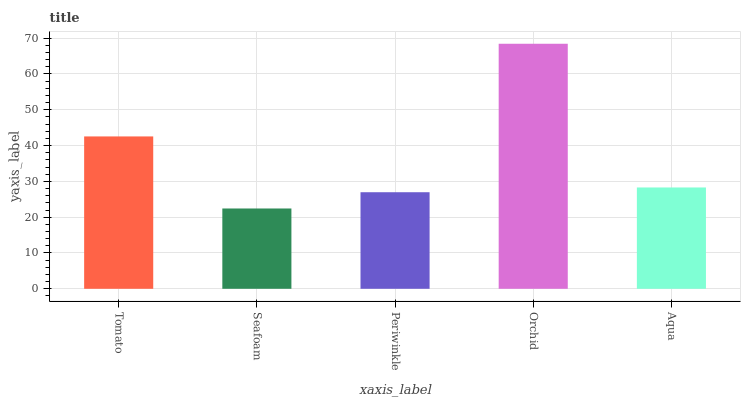Is Seafoam the minimum?
Answer yes or no. Yes. Is Orchid the maximum?
Answer yes or no. Yes. Is Periwinkle the minimum?
Answer yes or no. No. Is Periwinkle the maximum?
Answer yes or no. No. Is Periwinkle greater than Seafoam?
Answer yes or no. Yes. Is Seafoam less than Periwinkle?
Answer yes or no. Yes. Is Seafoam greater than Periwinkle?
Answer yes or no. No. Is Periwinkle less than Seafoam?
Answer yes or no. No. Is Aqua the high median?
Answer yes or no. Yes. Is Aqua the low median?
Answer yes or no. Yes. Is Tomato the high median?
Answer yes or no. No. Is Orchid the low median?
Answer yes or no. No. 